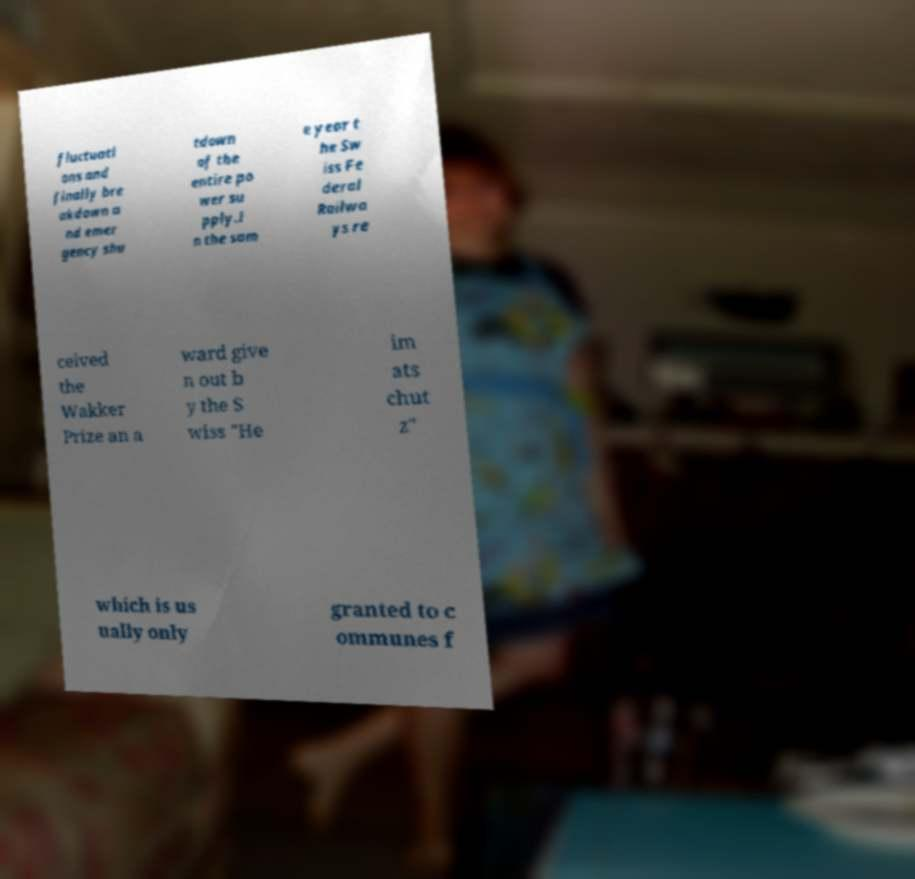There's text embedded in this image that I need extracted. Can you transcribe it verbatim? fluctuati ons and finally bre akdown a nd emer gency shu tdown of the entire po wer su pply.I n the sam e year t he Sw iss Fe deral Railwa ys re ceived the Wakker Prize an a ward give n out b y the S wiss "He im ats chut z" which is us ually only granted to c ommunes f 